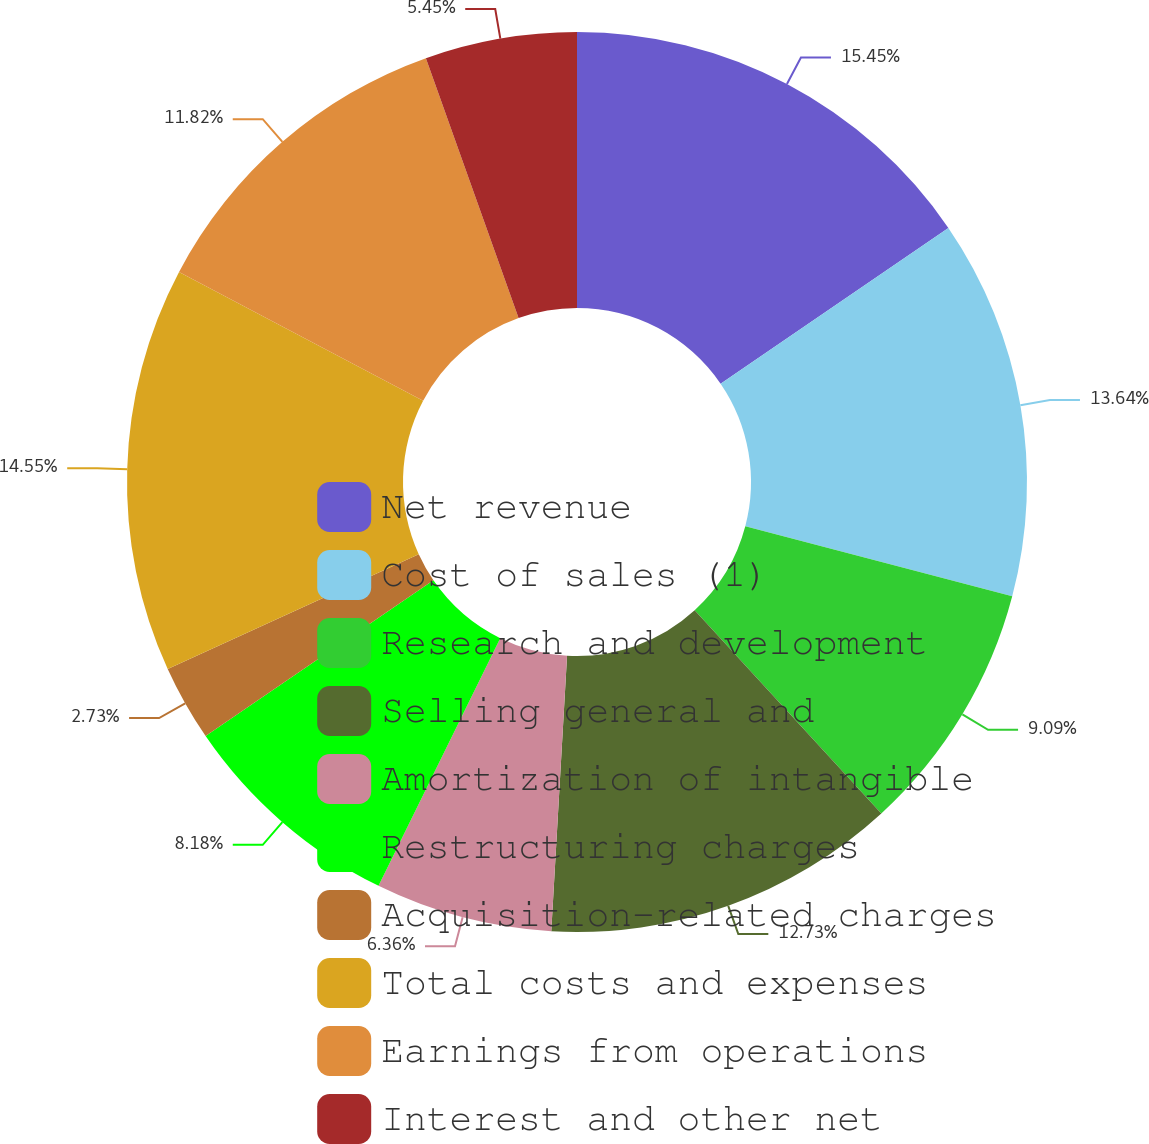<chart> <loc_0><loc_0><loc_500><loc_500><pie_chart><fcel>Net revenue<fcel>Cost of sales (1)<fcel>Research and development<fcel>Selling general and<fcel>Amortization of intangible<fcel>Restructuring charges<fcel>Acquisition-related charges<fcel>Total costs and expenses<fcel>Earnings from operations<fcel>Interest and other net<nl><fcel>15.45%<fcel>13.64%<fcel>9.09%<fcel>12.73%<fcel>6.36%<fcel>8.18%<fcel>2.73%<fcel>14.55%<fcel>11.82%<fcel>5.45%<nl></chart> 